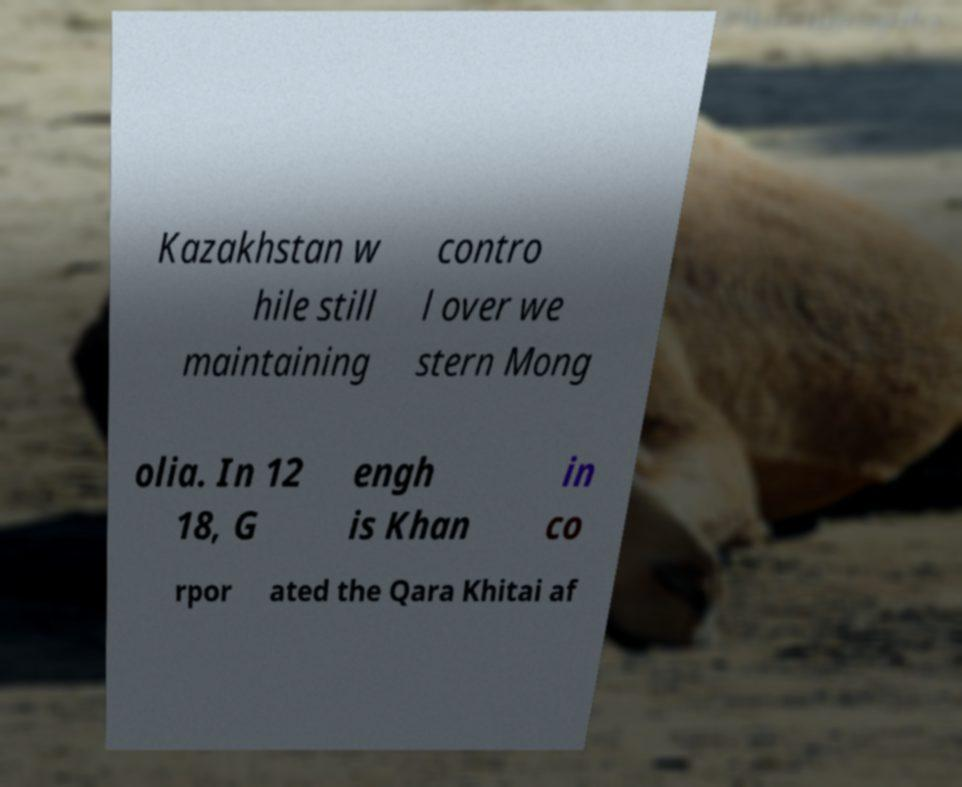Could you assist in decoding the text presented in this image and type it out clearly? Kazakhstan w hile still maintaining contro l over we stern Mong olia. In 12 18, G engh is Khan in co rpor ated the Qara Khitai af 